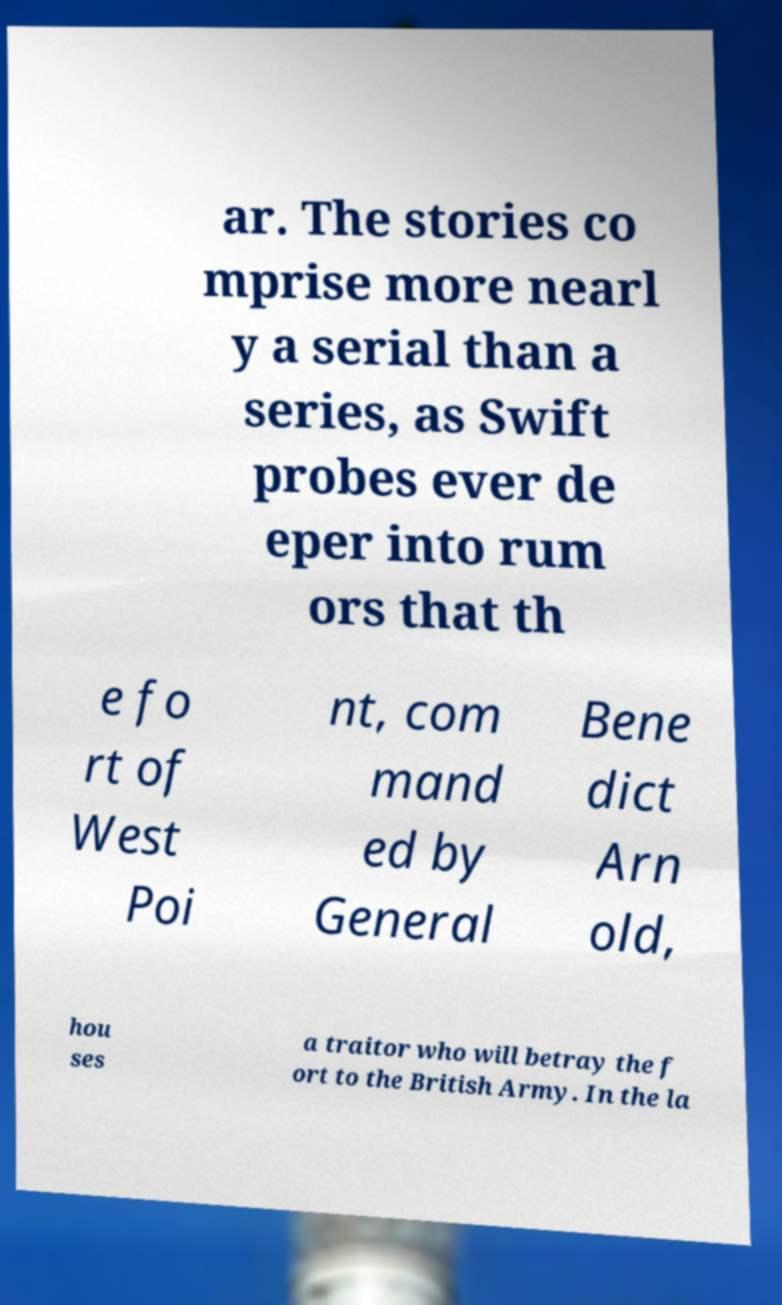Can you read and provide the text displayed in the image?This photo seems to have some interesting text. Can you extract and type it out for me? ar. The stories co mprise more nearl y a serial than a series, as Swift probes ever de eper into rum ors that th e fo rt of West Poi nt, com mand ed by General Bene dict Arn old, hou ses a traitor who will betray the f ort to the British Army. In the la 